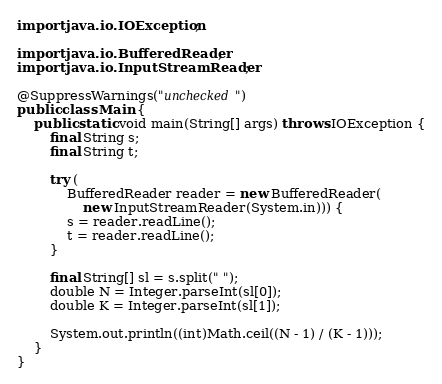<code> <loc_0><loc_0><loc_500><loc_500><_Java_>import java.io.IOException;

import java.io.BufferedReader;
import java.io.InputStreamReader;

@SuppressWarnings("unchecked")
public class Main {
    public static void main(String[] args) throws IOException {
        final String s;
        final String t;

        try (
            BufferedReader reader = new BufferedReader(
                new InputStreamReader(System.in))) {
            s = reader.readLine();
            t = reader.readLine();
        }

        final String[] sl = s.split(" ");
        double N = Integer.parseInt(sl[0]);
        double K = Integer.parseInt(sl[1]);

        System.out.println((int)Math.ceil((N - 1) / (K - 1)));
    }
}
</code> 